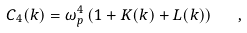<formula> <loc_0><loc_0><loc_500><loc_500>C _ { 4 } ( k ) = \omega _ { p } ^ { 4 } \, ( 1 + K ( k ) + L ( k ) ) \quad ,</formula> 